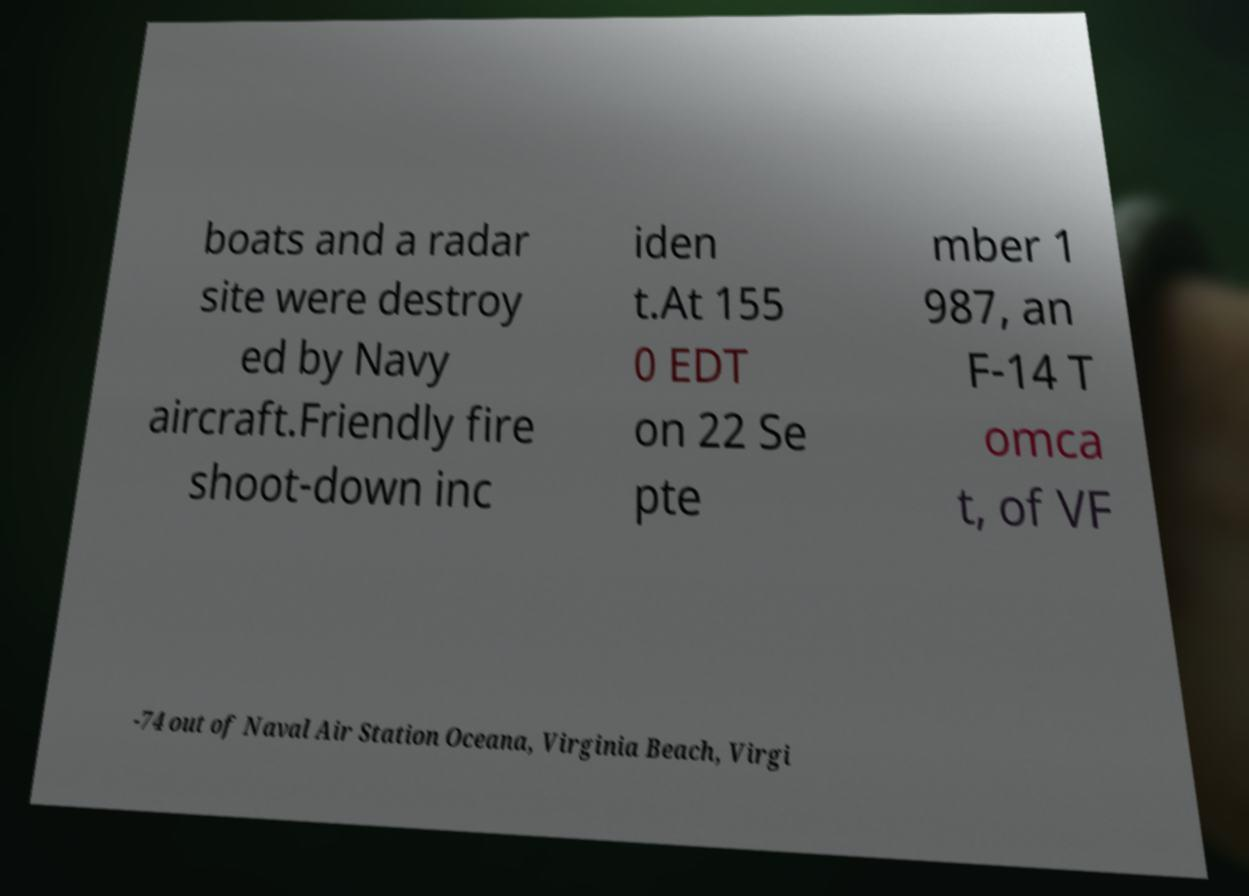I need the written content from this picture converted into text. Can you do that? boats and a radar site were destroy ed by Navy aircraft.Friendly fire shoot-down inc iden t.At 155 0 EDT on 22 Se pte mber 1 987, an F-14 T omca t, of VF -74 out of Naval Air Station Oceana, Virginia Beach, Virgi 